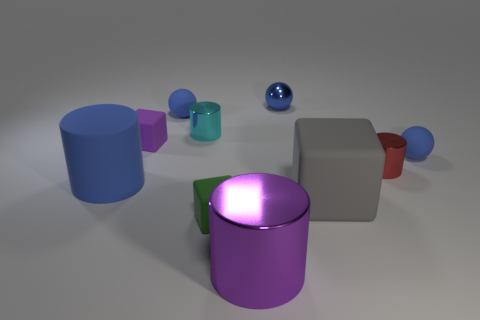Is the size of the cyan shiny object the same as the gray rubber block in front of the purple matte cube?
Provide a short and direct response. No. How many other objects are there of the same size as the purple metal cylinder?
Provide a succinct answer. 2. What number of other objects are the same color as the small shiny sphere?
Give a very brief answer. 3. Is there any other thing that is the same size as the blue rubber cylinder?
Offer a very short reply. Yes. What number of other things are there of the same shape as the small red object?
Your answer should be very brief. 3. Do the green rubber cube and the red shiny object have the same size?
Provide a succinct answer. Yes. Is there a small green block?
Your answer should be very brief. Yes. Is there anything else that is made of the same material as the small red cylinder?
Make the answer very short. Yes. Are there any small cylinders made of the same material as the tiny green cube?
Provide a succinct answer. No. What material is the cyan thing that is the same size as the purple matte thing?
Keep it short and to the point. Metal. 